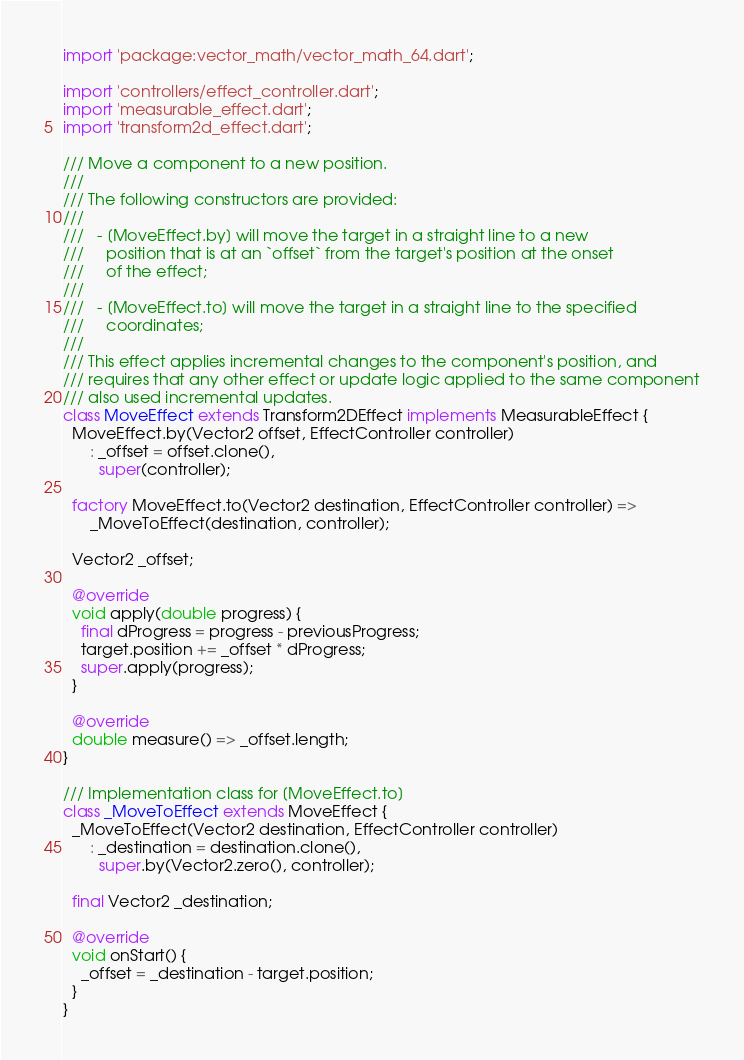Convert code to text. <code><loc_0><loc_0><loc_500><loc_500><_Dart_>import 'package:vector_math/vector_math_64.dart';

import 'controllers/effect_controller.dart';
import 'measurable_effect.dart';
import 'transform2d_effect.dart';

/// Move a component to a new position.
///
/// The following constructors are provided:
///
///   - [MoveEffect.by] will move the target in a straight line to a new
///     position that is at an `offset` from the target's position at the onset
///     of the effect;
///
///   - [MoveEffect.to] will move the target in a straight line to the specified
///     coordinates;
///
/// This effect applies incremental changes to the component's position, and
/// requires that any other effect or update logic applied to the same component
/// also used incremental updates.
class MoveEffect extends Transform2DEffect implements MeasurableEffect {
  MoveEffect.by(Vector2 offset, EffectController controller)
      : _offset = offset.clone(),
        super(controller);

  factory MoveEffect.to(Vector2 destination, EffectController controller) =>
      _MoveToEffect(destination, controller);

  Vector2 _offset;

  @override
  void apply(double progress) {
    final dProgress = progress - previousProgress;
    target.position += _offset * dProgress;
    super.apply(progress);
  }

  @override
  double measure() => _offset.length;
}

/// Implementation class for [MoveEffect.to]
class _MoveToEffect extends MoveEffect {
  _MoveToEffect(Vector2 destination, EffectController controller)
      : _destination = destination.clone(),
        super.by(Vector2.zero(), controller);

  final Vector2 _destination;

  @override
  void onStart() {
    _offset = _destination - target.position;
  }
}
</code> 